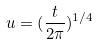Convert formula to latex. <formula><loc_0><loc_0><loc_500><loc_500>u = ( \frac { t } { 2 \pi } ) ^ { 1 / 4 }</formula> 